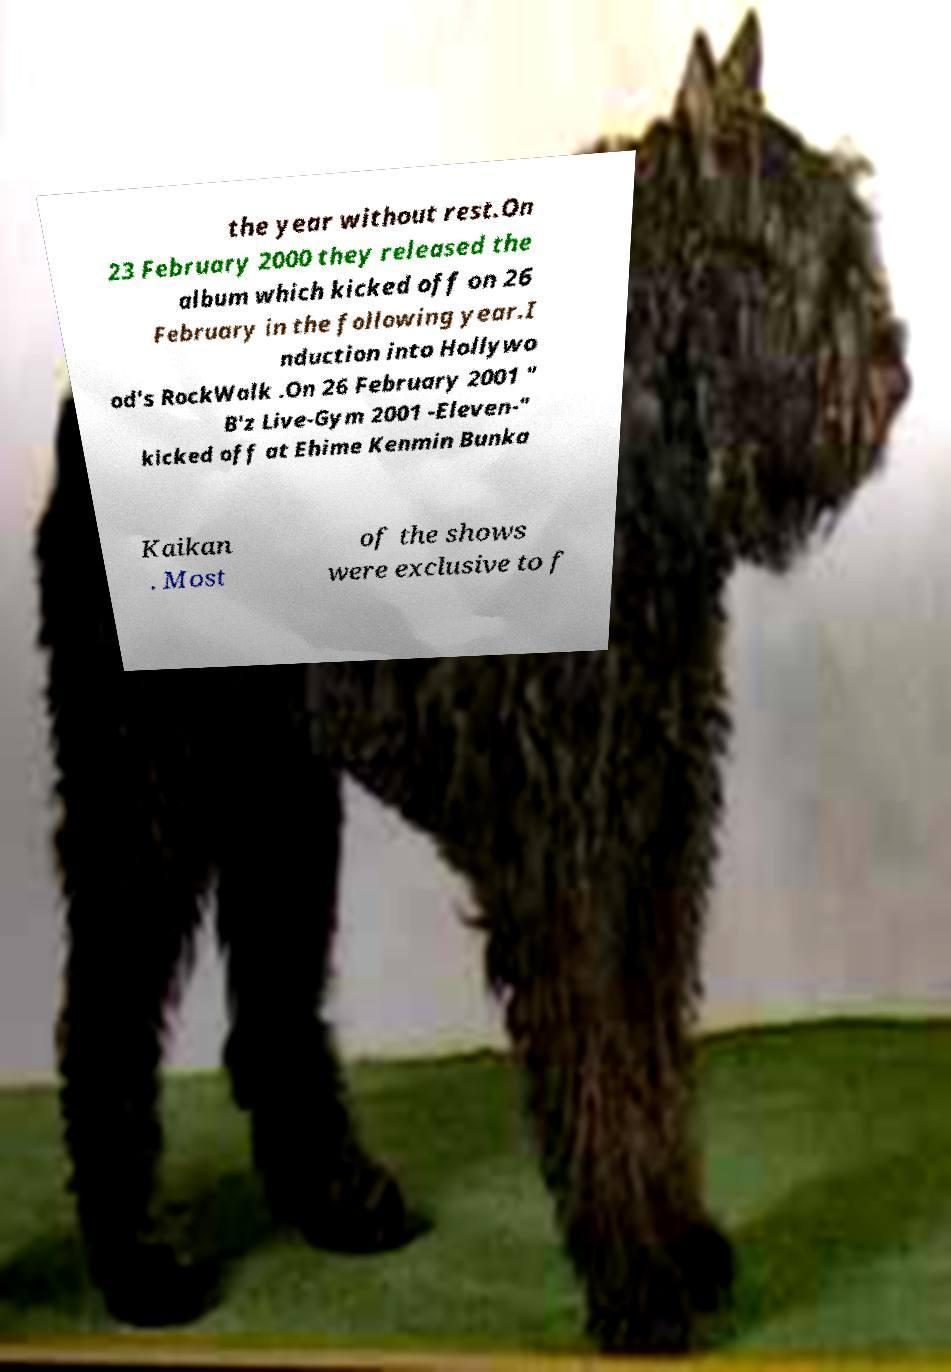Could you assist in decoding the text presented in this image and type it out clearly? the year without rest.On 23 February 2000 they released the album which kicked off on 26 February in the following year.I nduction into Hollywo od's RockWalk .On 26 February 2001 " B'z Live-Gym 2001 -Eleven-" kicked off at Ehime Kenmin Bunka Kaikan . Most of the shows were exclusive to f 